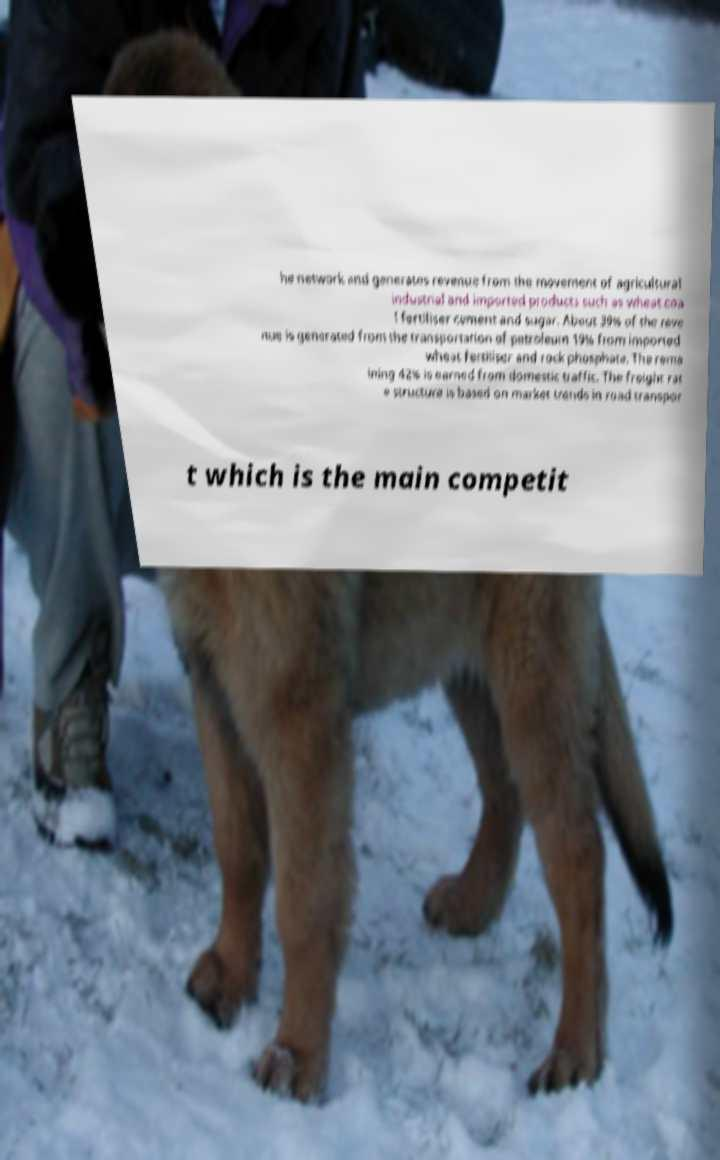For documentation purposes, I need the text within this image transcribed. Could you provide that? he network and generates revenue from the movement of agricultural industrial and imported products such as wheat coa l fertiliser cement and sugar. About 39% of the reve nue is generated from the transportation of petroleum 19% from imported wheat fertiliser and rock phosphate. The rema ining 42% is earned from domestic traffic. The freight rat e structure is based on market trends in road transpor t which is the main competit 